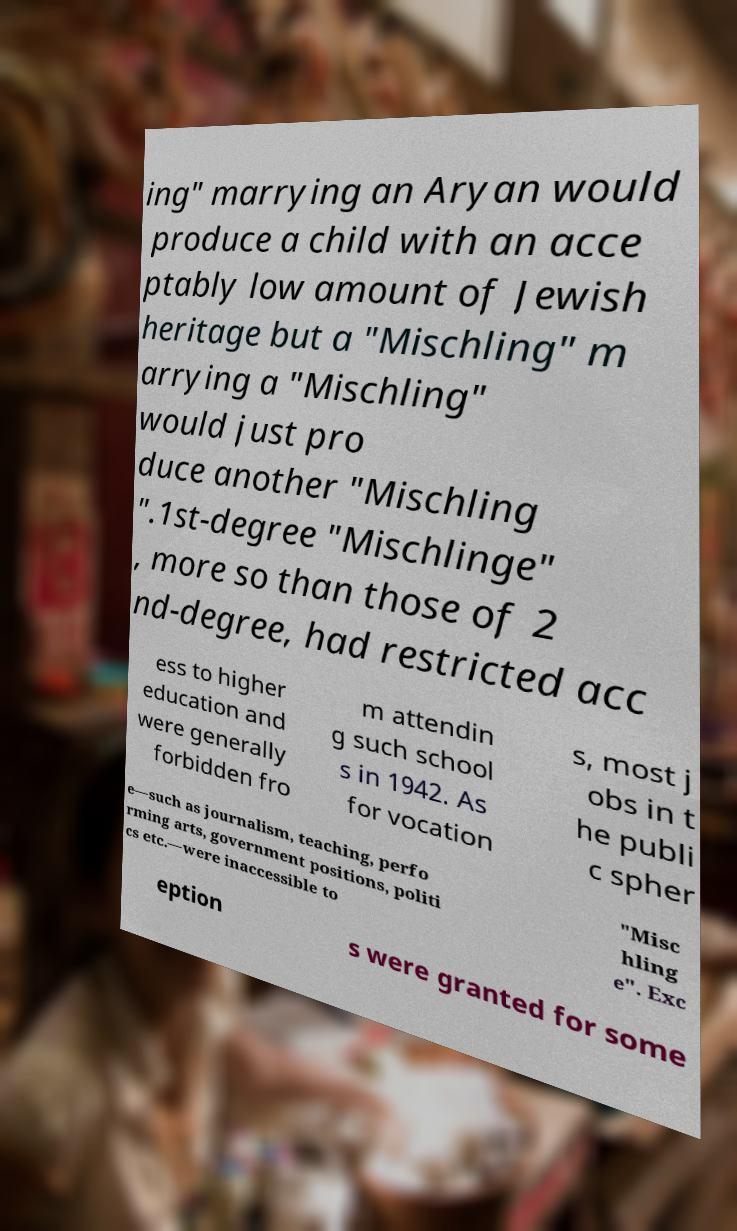For documentation purposes, I need the text within this image transcribed. Could you provide that? ing" marrying an Aryan would produce a child with an acce ptably low amount of Jewish heritage but a "Mischling" m arrying a "Mischling" would just pro duce another "Mischling ".1st-degree "Mischlinge" , more so than those of 2 nd-degree, had restricted acc ess to higher education and were generally forbidden fro m attendin g such school s in 1942. As for vocation s, most j obs in t he publi c spher e—such as journalism, teaching, perfo rming arts, government positions, politi cs etc.—were inaccessible to "Misc hling e". Exc eption s were granted for some 